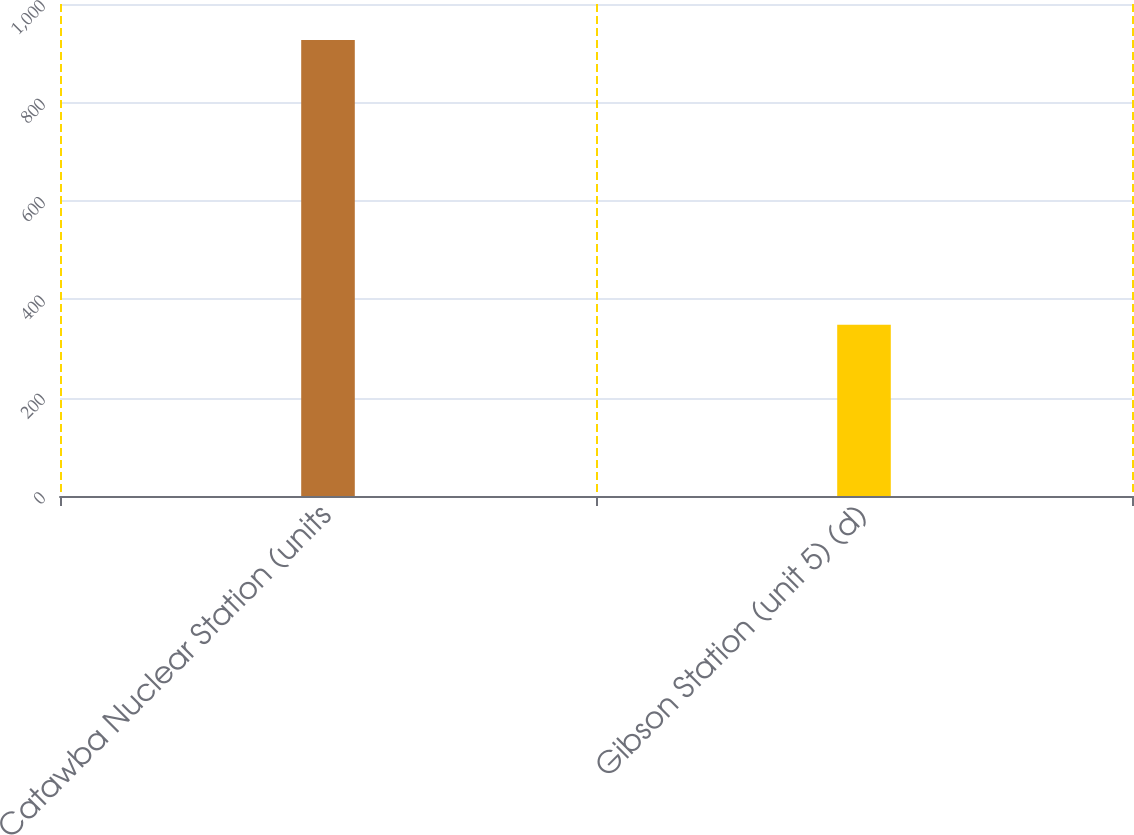<chart> <loc_0><loc_0><loc_500><loc_500><bar_chart><fcel>Catawba Nuclear Station (units<fcel>Gibson Station (unit 5) (d)<nl><fcel>927<fcel>348<nl></chart> 